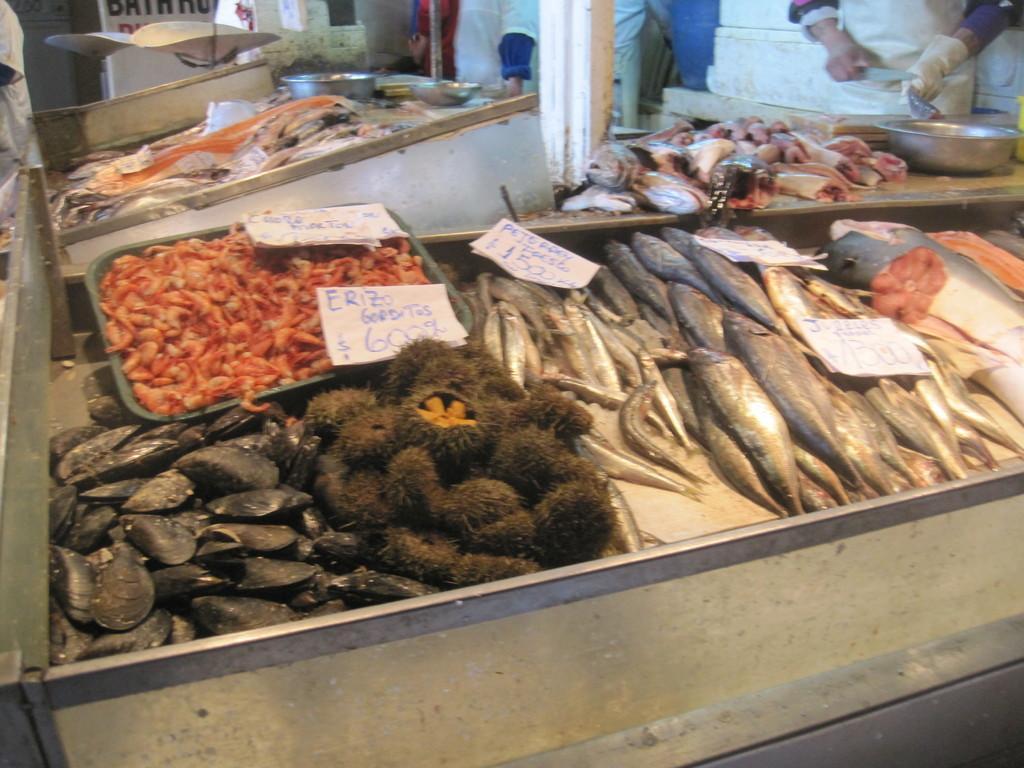In one or two sentences, can you explain what this image depicts? In the picture we can see a tray with a full of fishes of different types and besides in the small tray we can see some prawns which are red in color and in the background we can see some person is wearing an apron and gloves and cutting the fishes. 